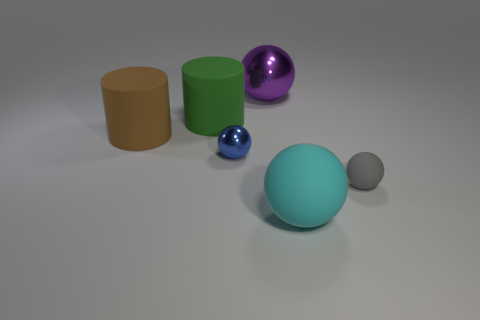Add 2 rubber spheres. How many objects exist? 8 Subtract all cylinders. How many objects are left? 4 Add 5 big green metallic cylinders. How many big green metallic cylinders exist? 5 Subtract 0 green blocks. How many objects are left? 6 Subtract all tiny brown things. Subtract all large metal objects. How many objects are left? 5 Add 1 tiny blue things. How many tiny blue things are left? 2 